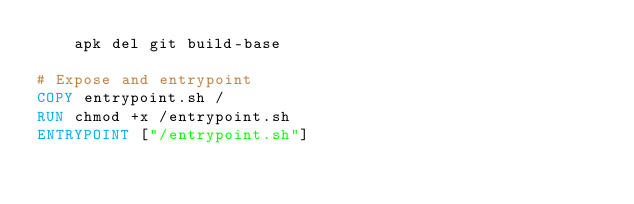<code> <loc_0><loc_0><loc_500><loc_500><_Dockerfile_>    apk del git build-base

# Expose and entrypoint
COPY entrypoint.sh /
RUN chmod +x /entrypoint.sh
ENTRYPOINT ["/entrypoint.sh"]
</code> 